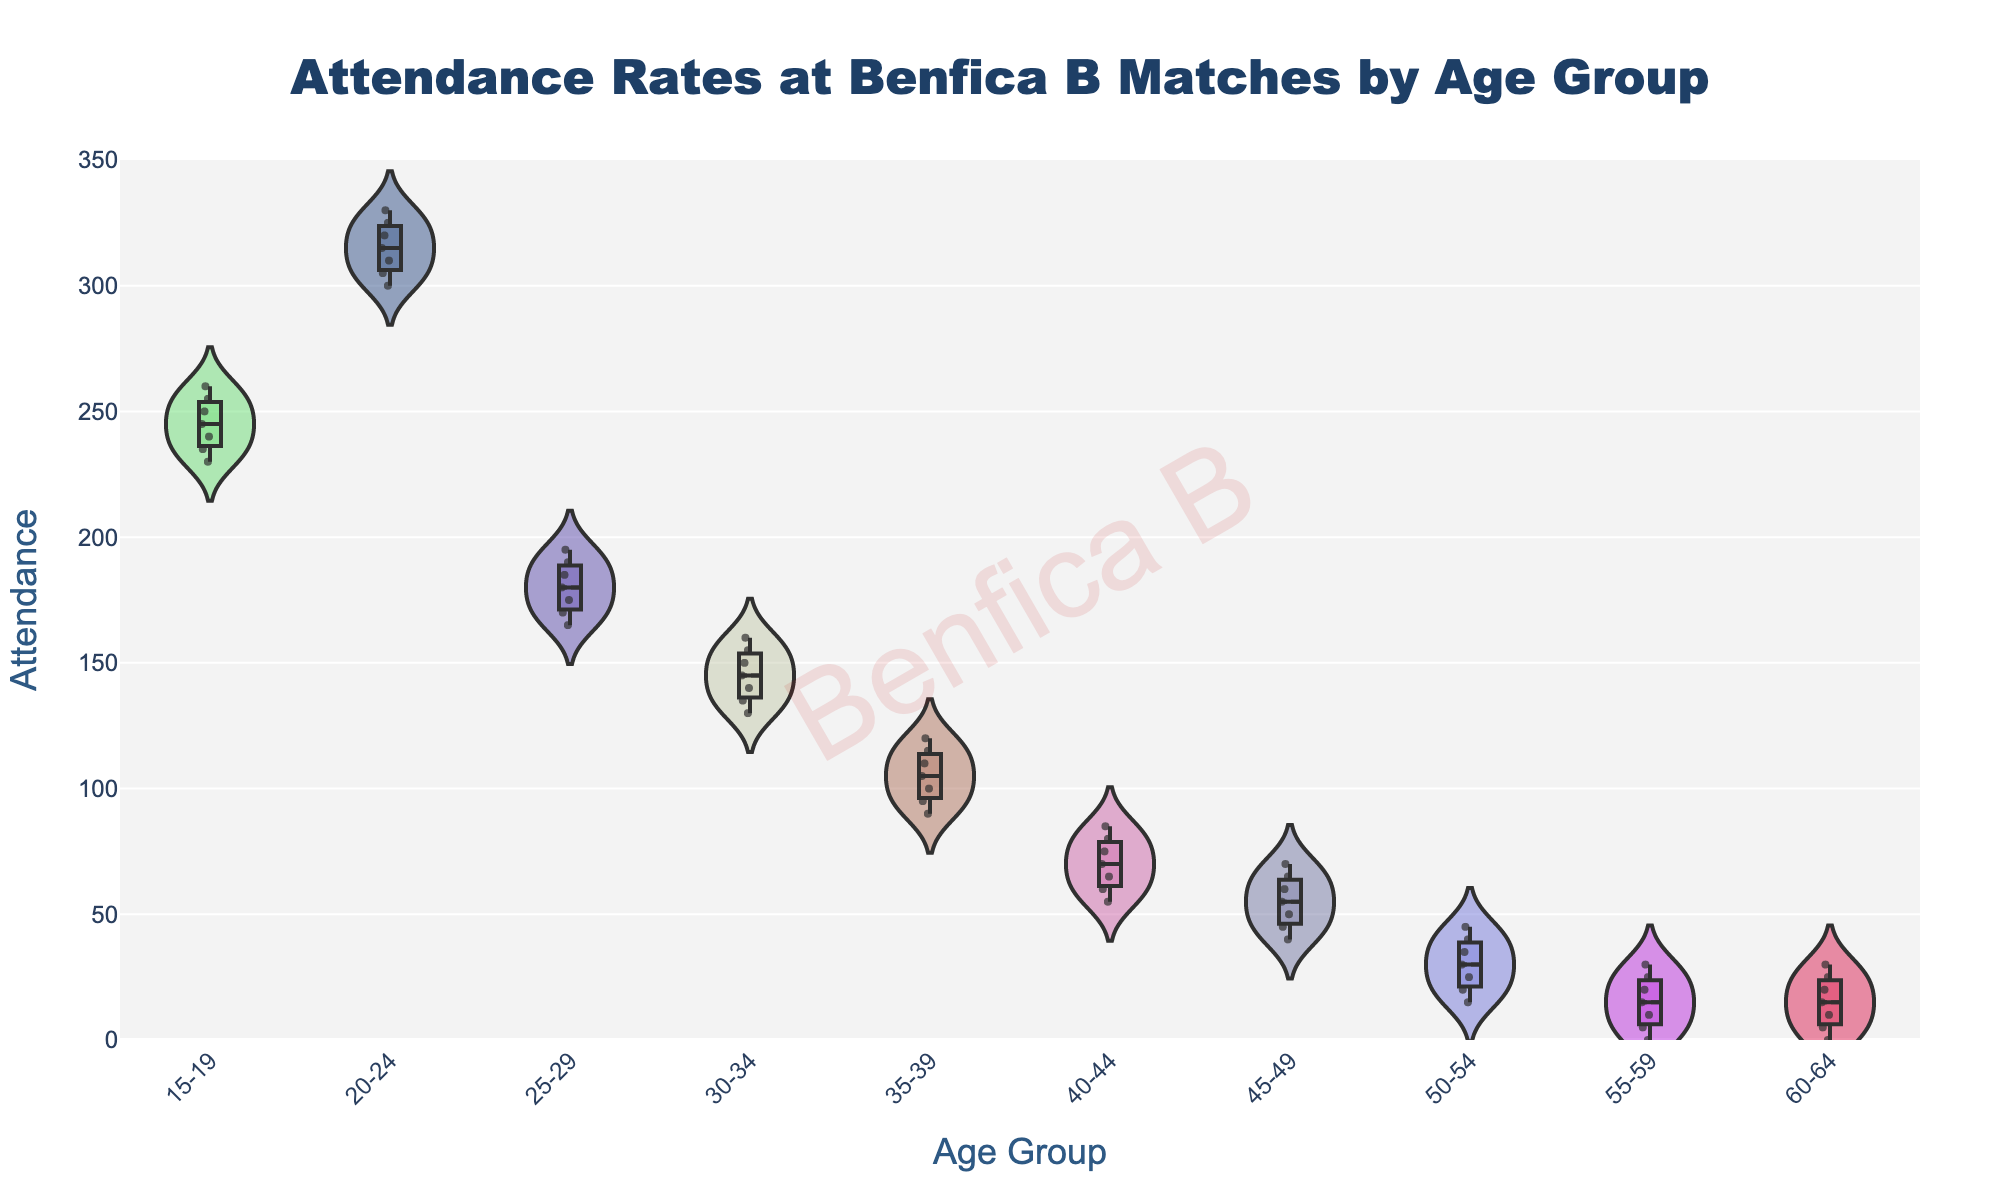What is the title of the figure? The title is located at the top-center of the figure. It is displayed in a noticeable size and font.
Answer: Attendance Rates at Benfica B Matches by Age Group Which age group has the highest median attendance? Examine the box plots within each violin plot to find the median line (usually the line in the middle of the box). The age group with the highest position of this line has the highest median attendance.
Answer: 20-24 Which age group has the broadest range of attendance rates? Look for the age group with the longest vertical spread in the violin plot. This indicates a larger range of attendance values.
Answer: 45-49 What is the median attendance for the 30-34 age group? Locate the median line within the box of the 30-34 age group in the figure. The position of this line represents the median attendance.
Answer: 145 Which age group has the least variance in attendance? Identify the age group where the spread of attendance values (both in the violin plot and the box plot) is the smallest.
Answer: 50-54 Are there any outliers in the age group 15-19? Check the box plot within the violin chart for the age group 15-19. Outliers are usually represented by individual points outside the whiskers of the box plot.
Answer: No Which two age groups have the closest median attendances? Compare the positions of the median lines in the box plots of all age groups to find the two that are closest to each other.
Answer: 15-19 and 25-29 For the 20-24 age group, what is the approximate interquartile range (IQR) of attendance? In the box plot for the 20-24 age group, the IQR is the range between the first quartile (bottom of the box) and the third quartile (top of the box). Estimate the values from the plot and calculate the difference.
Answer: 20 How does the attendance trend change with increasing age groups? Observe the overall pattern of attendance values across the increasing age groups from left to right in the figure. Note whether it generally increases, decreases, or stays constant.
Answer: Decreases What is the maximum attendance recorded for the 40-44 age group? Look at the highest point within the violin plot for the 40-44 age group to determine the maximum attendance value.
Answer: 85 